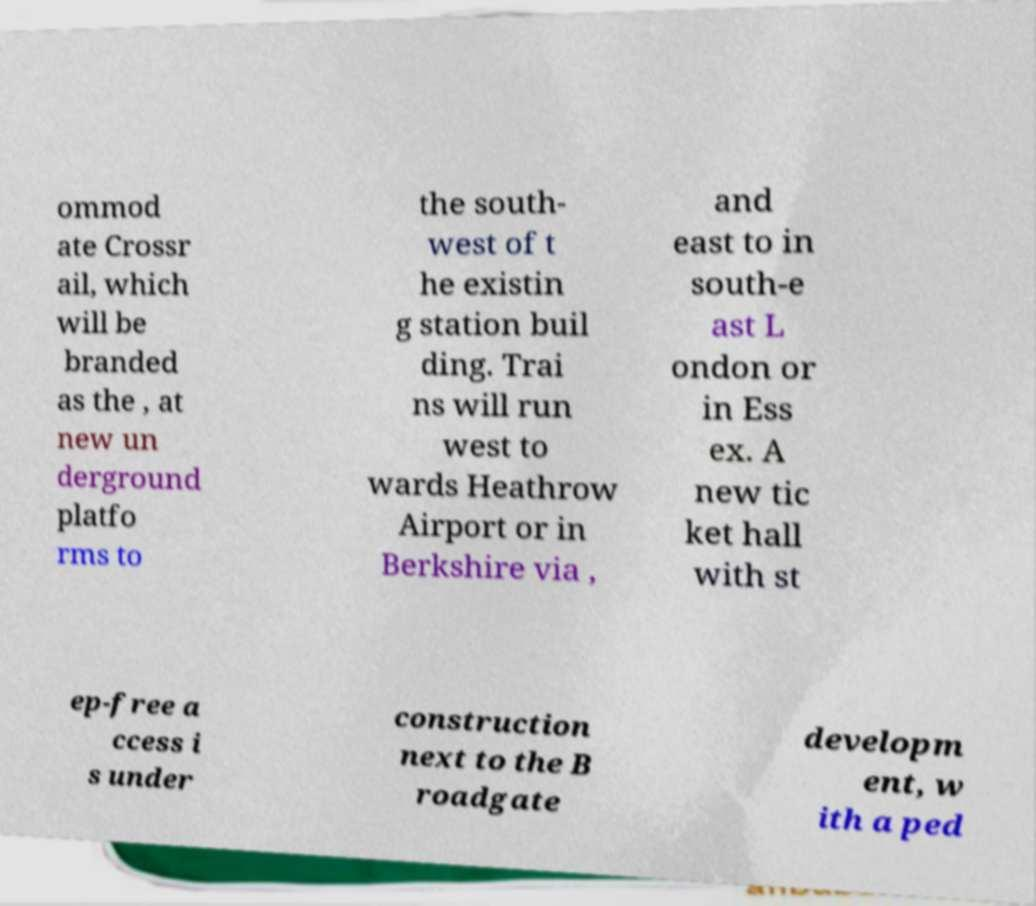For documentation purposes, I need the text within this image transcribed. Could you provide that? ommod ate Crossr ail, which will be branded as the , at new un derground platfo rms to the south- west of t he existin g station buil ding. Trai ns will run west to wards Heathrow Airport or in Berkshire via , and east to in south-e ast L ondon or in Ess ex. A new tic ket hall with st ep-free a ccess i s under construction next to the B roadgate developm ent, w ith a ped 